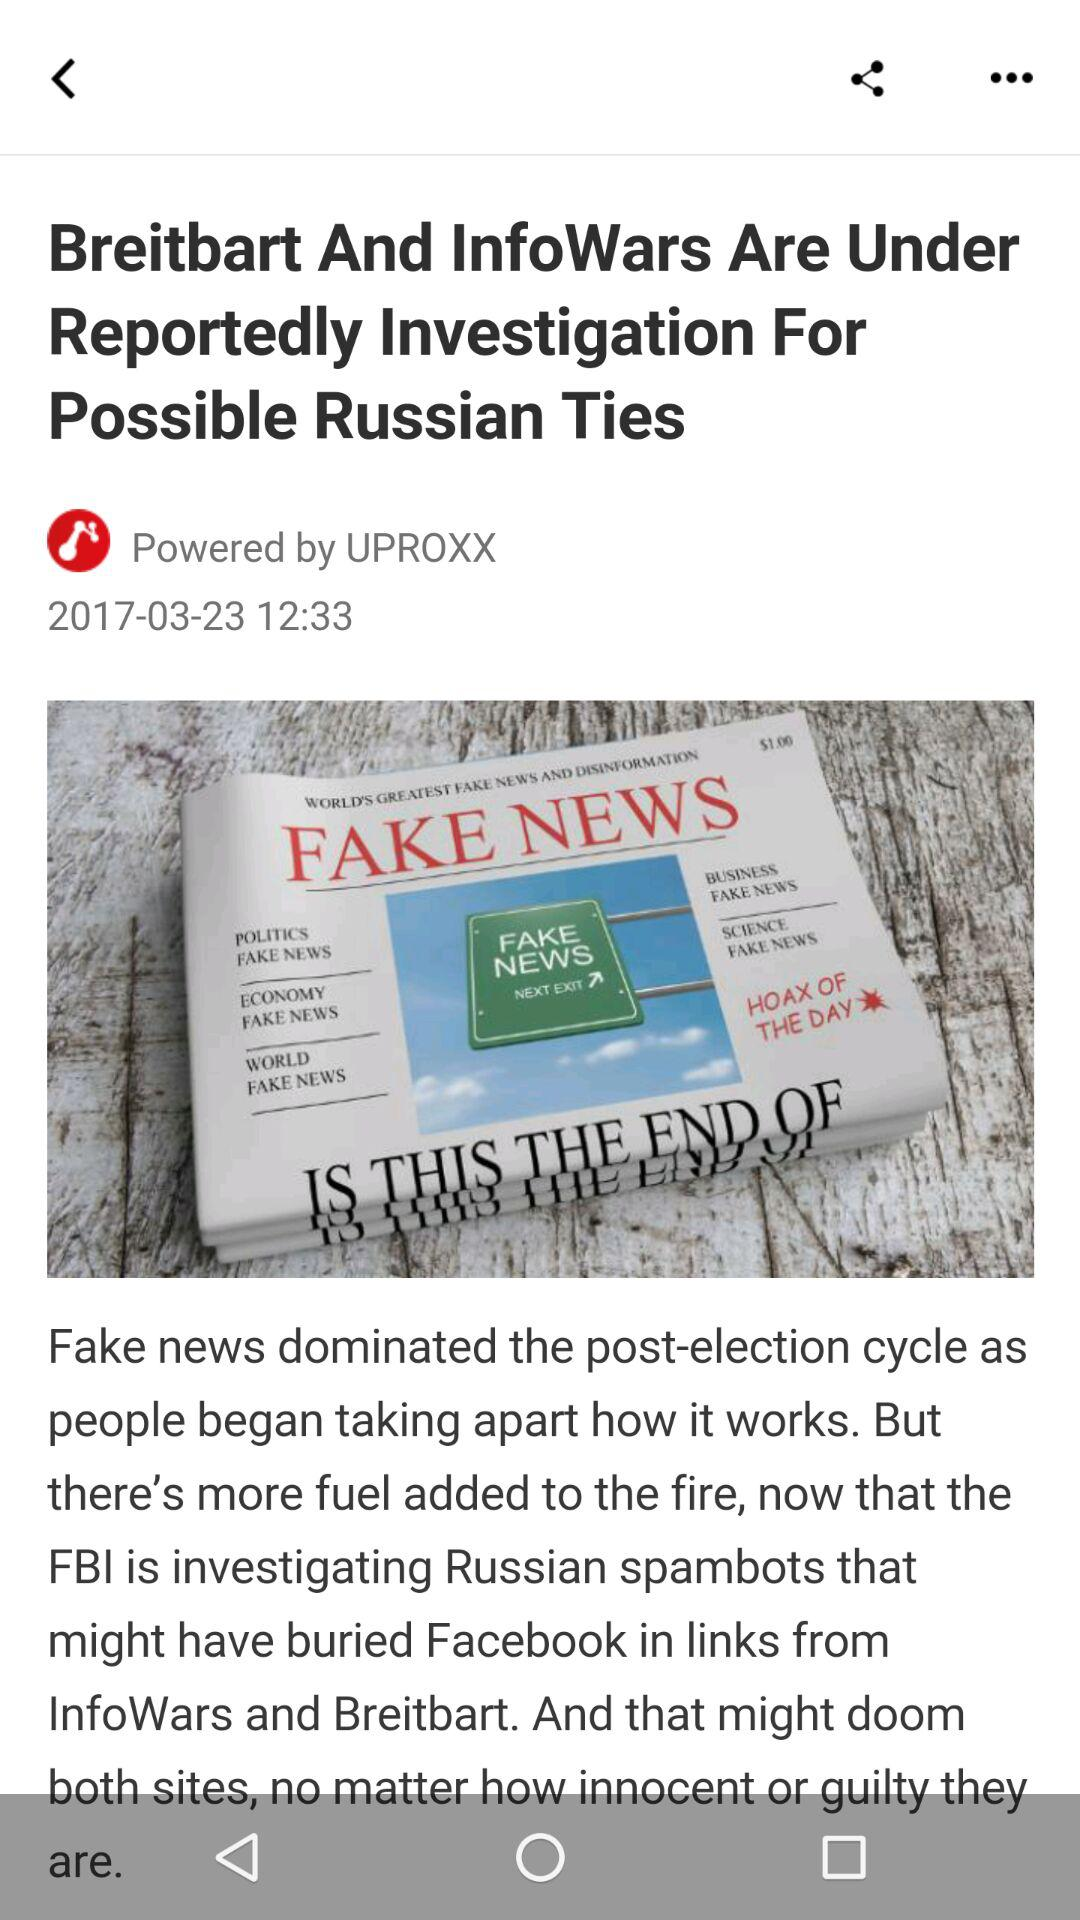What is the headline? The headline is "Breitbart And InfoWars Are Under Reportedly Investigation For Possible Russian Ties". 